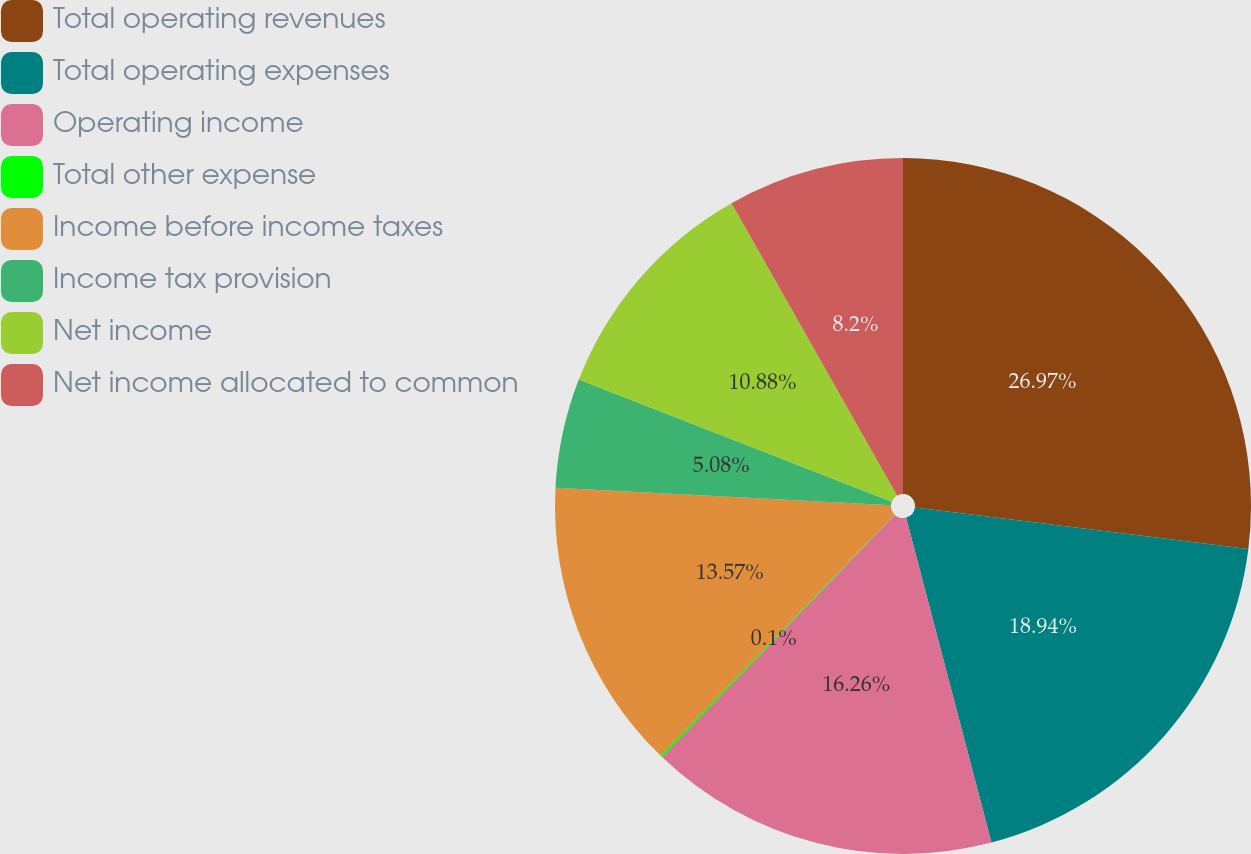<chart> <loc_0><loc_0><loc_500><loc_500><pie_chart><fcel>Total operating revenues<fcel>Total operating expenses<fcel>Operating income<fcel>Total other expense<fcel>Income before income taxes<fcel>Income tax provision<fcel>Net income<fcel>Net income allocated to common<nl><fcel>26.97%<fcel>18.94%<fcel>16.26%<fcel>0.1%<fcel>13.57%<fcel>5.08%<fcel>10.88%<fcel>8.2%<nl></chart> 